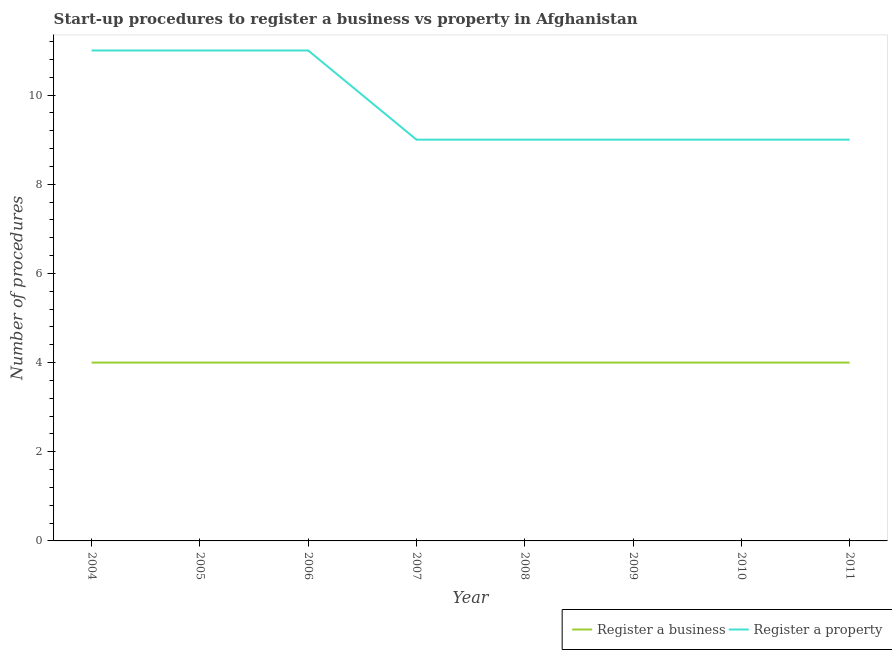How many different coloured lines are there?
Provide a short and direct response. 2. Does the line corresponding to number of procedures to register a business intersect with the line corresponding to number of procedures to register a property?
Your answer should be very brief. No. What is the number of procedures to register a property in 2009?
Your answer should be very brief. 9. Across all years, what is the maximum number of procedures to register a property?
Provide a succinct answer. 11. Across all years, what is the minimum number of procedures to register a property?
Your answer should be very brief. 9. In which year was the number of procedures to register a business maximum?
Give a very brief answer. 2004. In which year was the number of procedures to register a property minimum?
Your answer should be compact. 2007. What is the total number of procedures to register a property in the graph?
Give a very brief answer. 78. What is the difference between the number of procedures to register a property in 2009 and the number of procedures to register a business in 2007?
Your response must be concise. 5. In the year 2004, what is the difference between the number of procedures to register a property and number of procedures to register a business?
Ensure brevity in your answer.  7. What is the ratio of the number of procedures to register a property in 2005 to that in 2008?
Your answer should be very brief. 1.22. Is the difference between the number of procedures to register a property in 2005 and 2011 greater than the difference between the number of procedures to register a business in 2005 and 2011?
Provide a short and direct response. Yes. What is the difference between the highest and the second highest number of procedures to register a property?
Your response must be concise. 0. What is the difference between the highest and the lowest number of procedures to register a property?
Give a very brief answer. 2. In how many years, is the number of procedures to register a property greater than the average number of procedures to register a property taken over all years?
Provide a succinct answer. 3. What is the difference between two consecutive major ticks on the Y-axis?
Give a very brief answer. 2. Are the values on the major ticks of Y-axis written in scientific E-notation?
Make the answer very short. No. Where does the legend appear in the graph?
Provide a short and direct response. Bottom right. What is the title of the graph?
Your answer should be very brief. Start-up procedures to register a business vs property in Afghanistan. What is the label or title of the X-axis?
Provide a short and direct response. Year. What is the label or title of the Y-axis?
Your answer should be compact. Number of procedures. What is the Number of procedures in Register a business in 2005?
Your response must be concise. 4. What is the Number of procedures of Register a property in 2005?
Give a very brief answer. 11. What is the Number of procedures of Register a property in 2007?
Offer a very short reply. 9. What is the Number of procedures of Register a business in 2008?
Offer a very short reply. 4. What is the Number of procedures in Register a business in 2009?
Your response must be concise. 4. What is the Number of procedures in Register a property in 2009?
Ensure brevity in your answer.  9. What is the Number of procedures in Register a property in 2010?
Ensure brevity in your answer.  9. What is the Number of procedures in Register a business in 2011?
Your answer should be very brief. 4. Across all years, what is the maximum Number of procedures of Register a business?
Make the answer very short. 4. Across all years, what is the maximum Number of procedures in Register a property?
Your response must be concise. 11. Across all years, what is the minimum Number of procedures in Register a business?
Ensure brevity in your answer.  4. Across all years, what is the minimum Number of procedures in Register a property?
Ensure brevity in your answer.  9. What is the total Number of procedures in Register a property in the graph?
Offer a terse response. 78. What is the difference between the Number of procedures in Register a business in 2004 and that in 2005?
Your answer should be very brief. 0. What is the difference between the Number of procedures in Register a business in 2004 and that in 2007?
Your answer should be compact. 0. What is the difference between the Number of procedures of Register a business in 2004 and that in 2008?
Provide a short and direct response. 0. What is the difference between the Number of procedures of Register a property in 2004 and that in 2008?
Your answer should be very brief. 2. What is the difference between the Number of procedures in Register a property in 2004 and that in 2009?
Provide a short and direct response. 2. What is the difference between the Number of procedures in Register a property in 2004 and that in 2010?
Provide a short and direct response. 2. What is the difference between the Number of procedures of Register a property in 2004 and that in 2011?
Your answer should be very brief. 2. What is the difference between the Number of procedures of Register a business in 2005 and that in 2006?
Your answer should be very brief. 0. What is the difference between the Number of procedures of Register a business in 2005 and that in 2008?
Provide a short and direct response. 0. What is the difference between the Number of procedures of Register a property in 2005 and that in 2008?
Your response must be concise. 2. What is the difference between the Number of procedures of Register a property in 2005 and that in 2009?
Offer a very short reply. 2. What is the difference between the Number of procedures in Register a business in 2005 and that in 2010?
Give a very brief answer. 0. What is the difference between the Number of procedures in Register a business in 2005 and that in 2011?
Your response must be concise. 0. What is the difference between the Number of procedures of Register a business in 2006 and that in 2007?
Ensure brevity in your answer.  0. What is the difference between the Number of procedures in Register a business in 2006 and that in 2008?
Your response must be concise. 0. What is the difference between the Number of procedures of Register a property in 2006 and that in 2008?
Offer a terse response. 2. What is the difference between the Number of procedures of Register a business in 2006 and that in 2009?
Offer a terse response. 0. What is the difference between the Number of procedures of Register a property in 2006 and that in 2010?
Offer a very short reply. 2. What is the difference between the Number of procedures of Register a business in 2006 and that in 2011?
Your answer should be very brief. 0. What is the difference between the Number of procedures of Register a property in 2006 and that in 2011?
Provide a short and direct response. 2. What is the difference between the Number of procedures in Register a property in 2007 and that in 2009?
Make the answer very short. 0. What is the difference between the Number of procedures of Register a business in 2007 and that in 2010?
Keep it short and to the point. 0. What is the difference between the Number of procedures in Register a property in 2007 and that in 2010?
Your answer should be compact. 0. What is the difference between the Number of procedures in Register a property in 2007 and that in 2011?
Provide a succinct answer. 0. What is the difference between the Number of procedures of Register a business in 2008 and that in 2009?
Provide a short and direct response. 0. What is the difference between the Number of procedures of Register a property in 2008 and that in 2010?
Make the answer very short. 0. What is the difference between the Number of procedures of Register a property in 2008 and that in 2011?
Provide a succinct answer. 0. What is the difference between the Number of procedures in Register a property in 2009 and that in 2010?
Keep it short and to the point. 0. What is the difference between the Number of procedures of Register a business in 2009 and that in 2011?
Offer a very short reply. 0. What is the difference between the Number of procedures in Register a business in 2010 and that in 2011?
Provide a succinct answer. 0. What is the difference between the Number of procedures in Register a business in 2004 and the Number of procedures in Register a property in 2007?
Make the answer very short. -5. What is the difference between the Number of procedures of Register a business in 2004 and the Number of procedures of Register a property in 2011?
Keep it short and to the point. -5. What is the difference between the Number of procedures of Register a business in 2005 and the Number of procedures of Register a property in 2006?
Offer a terse response. -7. What is the difference between the Number of procedures in Register a business in 2006 and the Number of procedures in Register a property in 2008?
Give a very brief answer. -5. What is the difference between the Number of procedures in Register a business in 2006 and the Number of procedures in Register a property in 2009?
Offer a very short reply. -5. What is the difference between the Number of procedures of Register a business in 2006 and the Number of procedures of Register a property in 2011?
Keep it short and to the point. -5. What is the difference between the Number of procedures in Register a business in 2007 and the Number of procedures in Register a property in 2011?
Provide a succinct answer. -5. What is the difference between the Number of procedures of Register a business in 2008 and the Number of procedures of Register a property in 2011?
Offer a terse response. -5. What is the difference between the Number of procedures in Register a business in 2009 and the Number of procedures in Register a property in 2011?
Keep it short and to the point. -5. What is the average Number of procedures of Register a business per year?
Your response must be concise. 4. What is the average Number of procedures in Register a property per year?
Your answer should be very brief. 9.75. In the year 2006, what is the difference between the Number of procedures of Register a business and Number of procedures of Register a property?
Provide a succinct answer. -7. In the year 2007, what is the difference between the Number of procedures of Register a business and Number of procedures of Register a property?
Your answer should be very brief. -5. In the year 2010, what is the difference between the Number of procedures in Register a business and Number of procedures in Register a property?
Offer a very short reply. -5. In the year 2011, what is the difference between the Number of procedures in Register a business and Number of procedures in Register a property?
Provide a succinct answer. -5. What is the ratio of the Number of procedures in Register a business in 2004 to that in 2006?
Your response must be concise. 1. What is the ratio of the Number of procedures of Register a property in 2004 to that in 2006?
Make the answer very short. 1. What is the ratio of the Number of procedures of Register a property in 2004 to that in 2007?
Keep it short and to the point. 1.22. What is the ratio of the Number of procedures in Register a property in 2004 to that in 2008?
Your response must be concise. 1.22. What is the ratio of the Number of procedures of Register a business in 2004 to that in 2009?
Provide a short and direct response. 1. What is the ratio of the Number of procedures in Register a property in 2004 to that in 2009?
Provide a short and direct response. 1.22. What is the ratio of the Number of procedures of Register a property in 2004 to that in 2010?
Give a very brief answer. 1.22. What is the ratio of the Number of procedures in Register a business in 2004 to that in 2011?
Your answer should be very brief. 1. What is the ratio of the Number of procedures of Register a property in 2004 to that in 2011?
Your response must be concise. 1.22. What is the ratio of the Number of procedures of Register a business in 2005 to that in 2007?
Offer a terse response. 1. What is the ratio of the Number of procedures in Register a property in 2005 to that in 2007?
Provide a succinct answer. 1.22. What is the ratio of the Number of procedures in Register a business in 2005 to that in 2008?
Offer a terse response. 1. What is the ratio of the Number of procedures of Register a property in 2005 to that in 2008?
Offer a very short reply. 1.22. What is the ratio of the Number of procedures of Register a property in 2005 to that in 2009?
Provide a short and direct response. 1.22. What is the ratio of the Number of procedures of Register a business in 2005 to that in 2010?
Offer a very short reply. 1. What is the ratio of the Number of procedures of Register a property in 2005 to that in 2010?
Offer a very short reply. 1.22. What is the ratio of the Number of procedures of Register a business in 2005 to that in 2011?
Offer a terse response. 1. What is the ratio of the Number of procedures in Register a property in 2005 to that in 2011?
Your response must be concise. 1.22. What is the ratio of the Number of procedures in Register a business in 2006 to that in 2007?
Give a very brief answer. 1. What is the ratio of the Number of procedures in Register a property in 2006 to that in 2007?
Your answer should be very brief. 1.22. What is the ratio of the Number of procedures of Register a business in 2006 to that in 2008?
Provide a short and direct response. 1. What is the ratio of the Number of procedures in Register a property in 2006 to that in 2008?
Provide a succinct answer. 1.22. What is the ratio of the Number of procedures of Register a business in 2006 to that in 2009?
Give a very brief answer. 1. What is the ratio of the Number of procedures in Register a property in 2006 to that in 2009?
Ensure brevity in your answer.  1.22. What is the ratio of the Number of procedures in Register a business in 2006 to that in 2010?
Provide a succinct answer. 1. What is the ratio of the Number of procedures of Register a property in 2006 to that in 2010?
Provide a succinct answer. 1.22. What is the ratio of the Number of procedures in Register a property in 2006 to that in 2011?
Keep it short and to the point. 1.22. What is the ratio of the Number of procedures in Register a business in 2007 to that in 2008?
Provide a succinct answer. 1. What is the ratio of the Number of procedures of Register a property in 2007 to that in 2009?
Offer a terse response. 1. What is the ratio of the Number of procedures in Register a property in 2007 to that in 2011?
Your answer should be compact. 1. What is the ratio of the Number of procedures of Register a business in 2008 to that in 2009?
Your response must be concise. 1. What is the ratio of the Number of procedures in Register a business in 2008 to that in 2010?
Ensure brevity in your answer.  1. What is the ratio of the Number of procedures in Register a business in 2008 to that in 2011?
Offer a terse response. 1. What is the ratio of the Number of procedures in Register a property in 2009 to that in 2010?
Your answer should be compact. 1. What is the ratio of the Number of procedures in Register a property in 2009 to that in 2011?
Offer a terse response. 1. What is the ratio of the Number of procedures of Register a property in 2010 to that in 2011?
Make the answer very short. 1. What is the difference between the highest and the second highest Number of procedures in Register a business?
Make the answer very short. 0. What is the difference between the highest and the lowest Number of procedures of Register a property?
Provide a succinct answer. 2. 